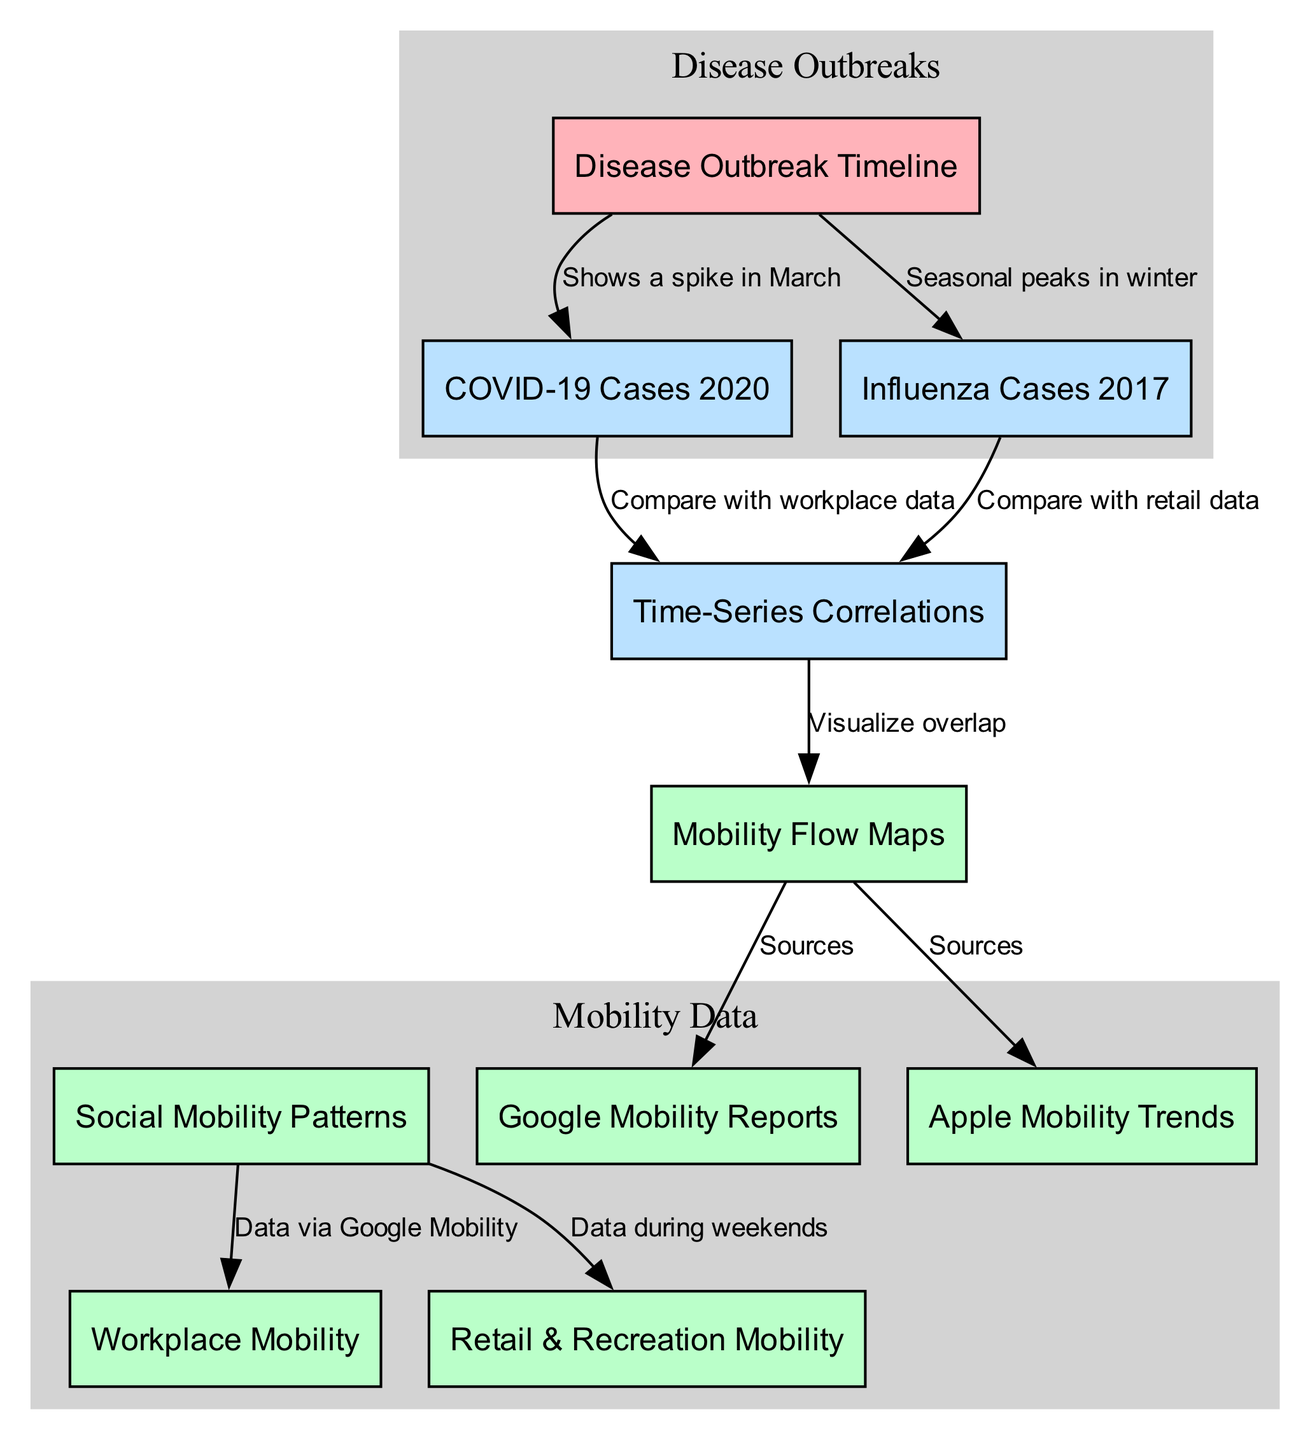What is the label of the node that represents the timeline of disease outbreaks? The diagram includes a node labeled "Disease Outbreak Timeline," which represents the overall timeline associated with various disease outbreaks.
Answer: Disease Outbreak Timeline How many nodes are present in the diagram? By counting each unique node listed in the diagram, there is a total of 10 nodes that represent either disease outbreaks or mobility patterns.
Answer: 10 What label is associated with the node that shows seasonal peaks in winter? There is a node explicitly labeled "Influenza Cases 2017," which indicates that it shows seasonal peaks occurring during the winter.
Answer: Influenza Cases 2017 Which mobility data source is connected to workplace mobility patterns? The diagram suggests that "Workplace Mobility" is specifically connected to "Social Mobility Patterns," and the data source for this is indicated to be via Google Mobility.
Answer: Google Mobility What type of charts are discussed in relation to COVID-19 cases in 2020? The diagram indicates that "Time-Series Correlations" are being used to compare COVID-19 cases with workplace data, suggesting the use of time-series charts.
Answer: Time-Series Correlations Which two types of mobility reports are included as sources for mobility flow maps? The diagram indicates that "Mobility Flow Maps" utilize two data sources: "Google Mobility Reports" and "Apple Mobility Trends."
Answer: Google Mobility Reports and Apple Mobility Trends How does the diagram visualize the overlap between mobility patterns and disease outbreaks? The relationship indicated by the edge connecting "Time-Series Correlations" to "Mobility Flow Maps" shows that the visualization of their overlap is performed through that connection.
Answer: Visualize overlap What was observed in the COVID-19 cases timeline during March 2020? The diagram describes a spike in COVID-19 cases occurring in March, prominently depicting the increase in cases during that time.
Answer: Shows a spike in March In which part of the diagram is the data related to retail and recreation mobility highlighted? The "Retail & Recreation Mobility" node is connected to "Social Mobility Patterns," suggesting that it focuses on mobility data specifically during weekends, shown in the diagram.
Answer: Data during weekends 